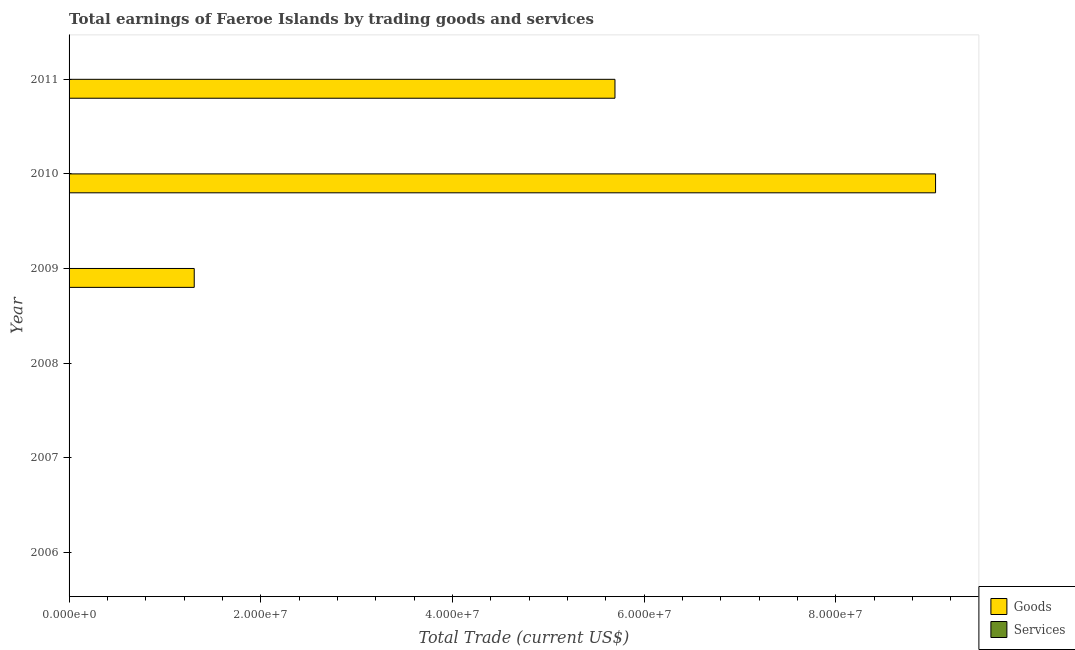What is the amount earned by trading goods in 2010?
Provide a succinct answer. 9.04e+07. Across all years, what is the maximum amount earned by trading goods?
Keep it short and to the point. 9.04e+07. What is the difference between the amount earned by trading goods in 2009 and that in 2011?
Give a very brief answer. -4.39e+07. What is the difference between the amount earned by trading goods in 2011 and the amount earned by trading services in 2007?
Your answer should be very brief. 5.70e+07. What is the average amount earned by trading services per year?
Offer a very short reply. 0. Is the amount earned by trading goods in 2009 less than that in 2011?
Offer a terse response. Yes. What is the difference between the highest and the second highest amount earned by trading goods?
Provide a succinct answer. 3.35e+07. What is the difference between the highest and the lowest amount earned by trading goods?
Provide a succinct answer. 9.04e+07. Are all the bars in the graph horizontal?
Your answer should be very brief. Yes. How many years are there in the graph?
Your answer should be compact. 6. Are the values on the major ticks of X-axis written in scientific E-notation?
Your response must be concise. Yes. How many legend labels are there?
Provide a short and direct response. 2. What is the title of the graph?
Keep it short and to the point. Total earnings of Faeroe Islands by trading goods and services. What is the label or title of the X-axis?
Ensure brevity in your answer.  Total Trade (current US$). What is the label or title of the Y-axis?
Your response must be concise. Year. What is the Total Trade (current US$) in Goods in 2008?
Provide a short and direct response. 0. What is the Total Trade (current US$) of Services in 2008?
Your response must be concise. 0. What is the Total Trade (current US$) in Goods in 2009?
Provide a short and direct response. 1.31e+07. What is the Total Trade (current US$) of Goods in 2010?
Your answer should be compact. 9.04e+07. What is the Total Trade (current US$) in Goods in 2011?
Give a very brief answer. 5.70e+07. What is the Total Trade (current US$) in Services in 2011?
Provide a succinct answer. 0. Across all years, what is the maximum Total Trade (current US$) in Goods?
Ensure brevity in your answer.  9.04e+07. Across all years, what is the minimum Total Trade (current US$) in Goods?
Provide a short and direct response. 0. What is the total Total Trade (current US$) of Goods in the graph?
Your answer should be very brief. 1.60e+08. What is the difference between the Total Trade (current US$) of Goods in 2009 and that in 2010?
Give a very brief answer. -7.74e+07. What is the difference between the Total Trade (current US$) in Goods in 2009 and that in 2011?
Offer a very short reply. -4.39e+07. What is the difference between the Total Trade (current US$) in Goods in 2010 and that in 2011?
Offer a very short reply. 3.35e+07. What is the average Total Trade (current US$) of Goods per year?
Give a very brief answer. 2.67e+07. What is the average Total Trade (current US$) in Services per year?
Give a very brief answer. 0. What is the ratio of the Total Trade (current US$) in Goods in 2009 to that in 2010?
Provide a succinct answer. 0.14. What is the ratio of the Total Trade (current US$) in Goods in 2009 to that in 2011?
Make the answer very short. 0.23. What is the ratio of the Total Trade (current US$) of Goods in 2010 to that in 2011?
Provide a short and direct response. 1.59. What is the difference between the highest and the second highest Total Trade (current US$) of Goods?
Your response must be concise. 3.35e+07. What is the difference between the highest and the lowest Total Trade (current US$) in Goods?
Offer a terse response. 9.04e+07. 